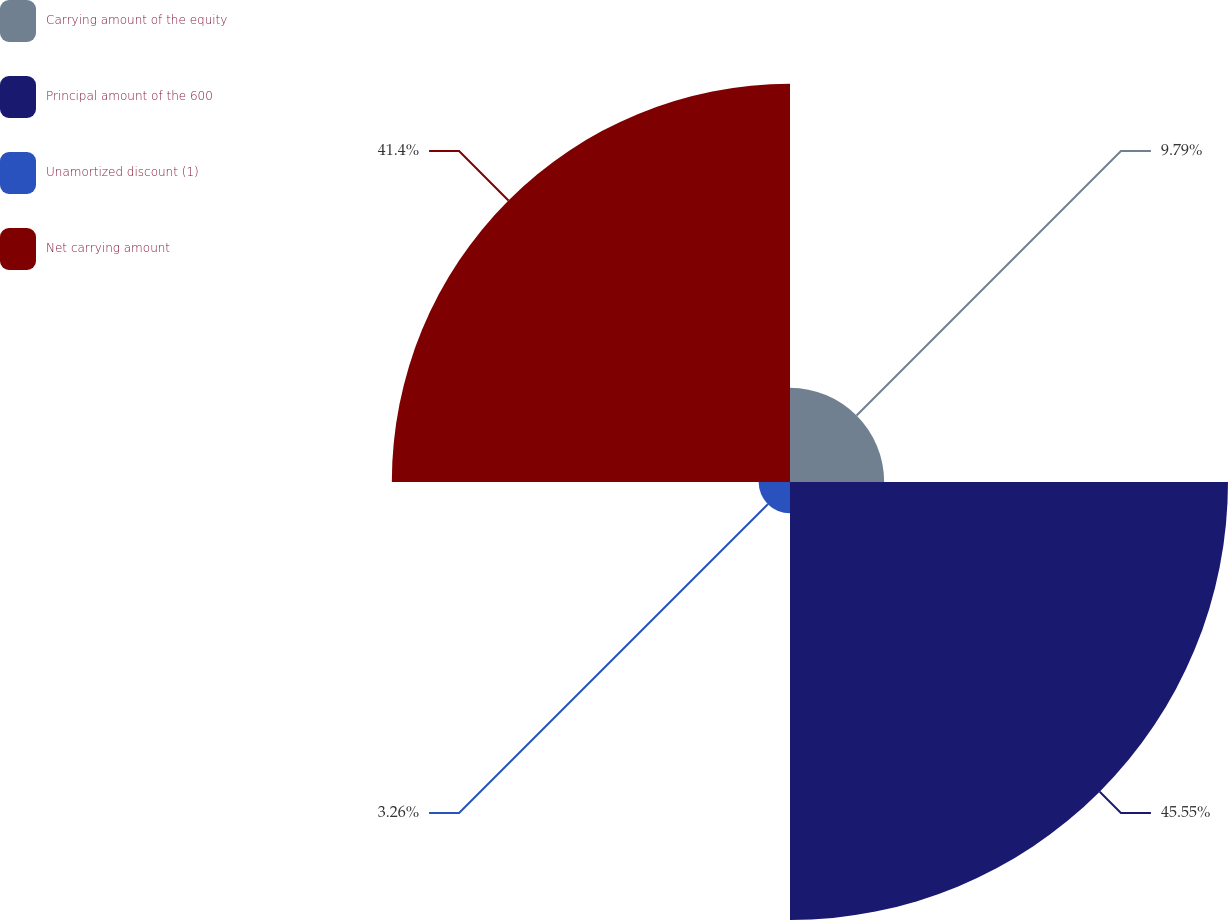<chart> <loc_0><loc_0><loc_500><loc_500><pie_chart><fcel>Carrying amount of the equity<fcel>Principal amount of the 600<fcel>Unamortized discount (1)<fcel>Net carrying amount<nl><fcel>9.79%<fcel>45.54%<fcel>3.26%<fcel>41.4%<nl></chart> 